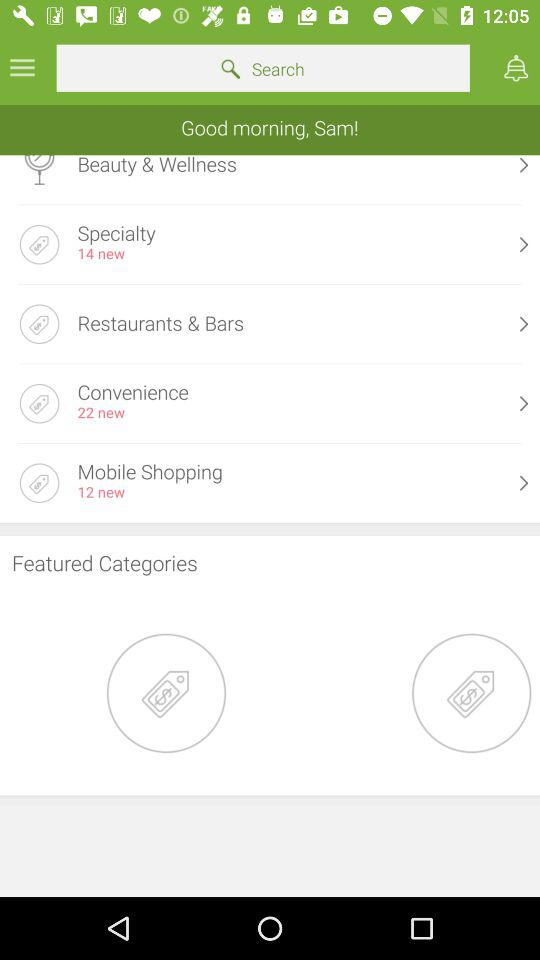How many new conveniences in total are there? There are 22 new conveniences in total. 